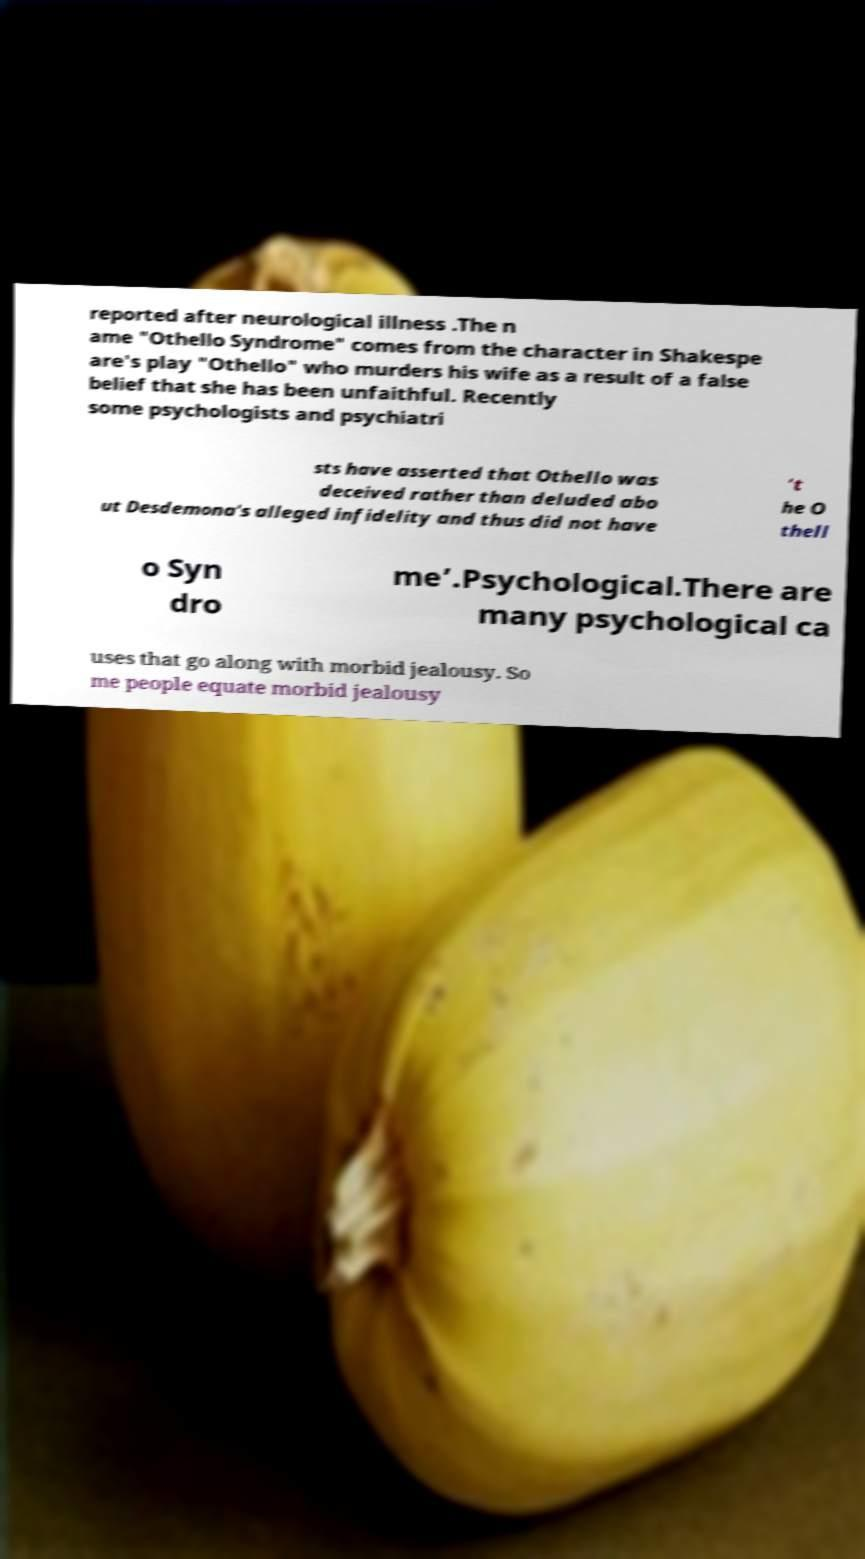There's text embedded in this image that I need extracted. Can you transcribe it verbatim? reported after neurological illness .The n ame "Othello Syndrome" comes from the character in Shakespe are's play "Othello" who murders his wife as a result of a false belief that she has been unfaithful. Recently some psychologists and psychiatri sts have asserted that Othello was deceived rather than deluded abo ut Desdemona's alleged infidelity and thus did not have ‘t he O thell o Syn dro me’.Psychological.There are many psychological ca uses that go along with morbid jealousy. So me people equate morbid jealousy 